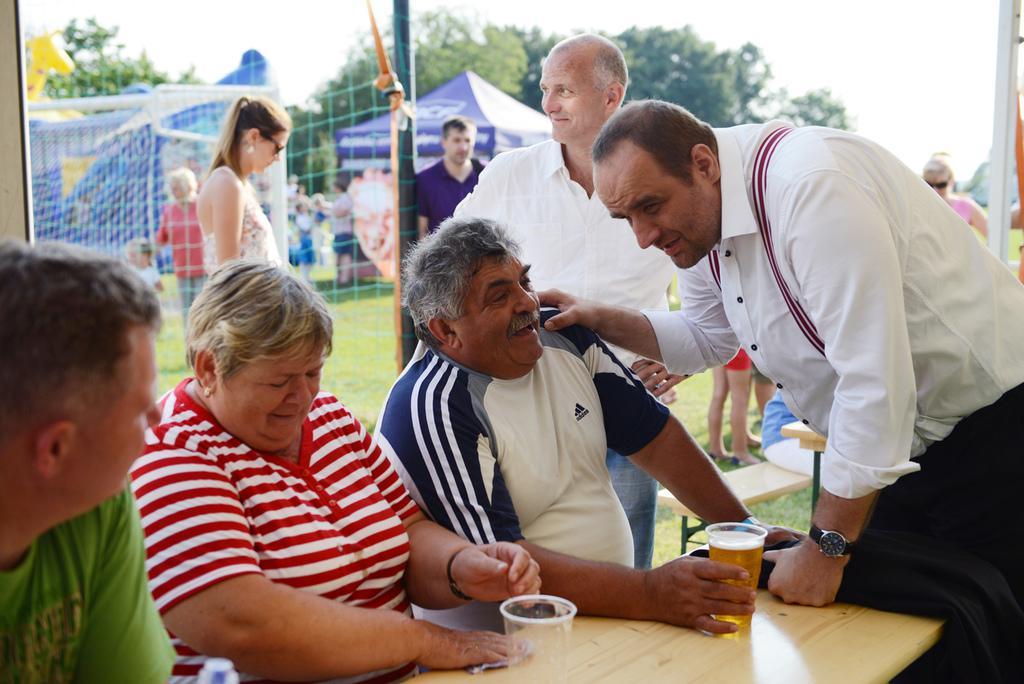How would you summarize this image in a sentence or two? There are three people sitting in a chair and there is a table in front of them which has a glass of wine in it and there is a other person in the right corner standing in front of them. There are group of people and trees behind them. 